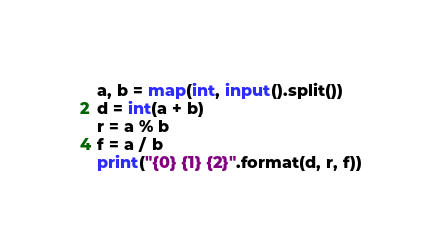Convert code to text. <code><loc_0><loc_0><loc_500><loc_500><_Python_>a, b = map(int, input().split())
d = int(a + b)
r = a % b
f = a / b
print("{0} {1} {2}".format(d, r, f))</code> 